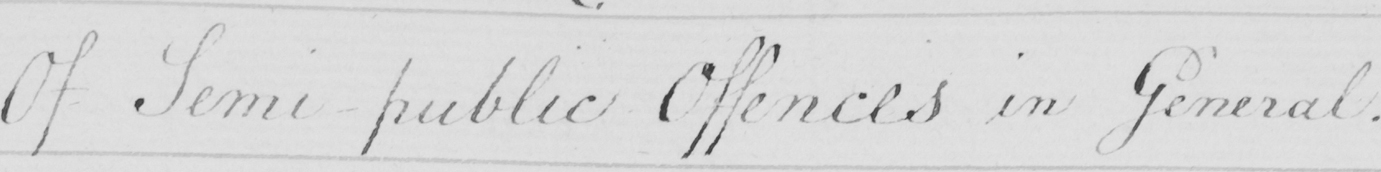Please transcribe the handwritten text in this image. Of Semi-public Offences in General . 